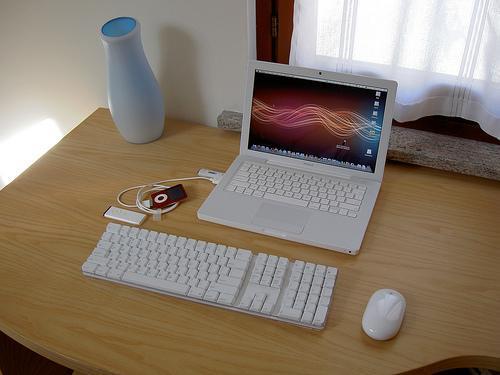How many windows?
Give a very brief answer. 1. 